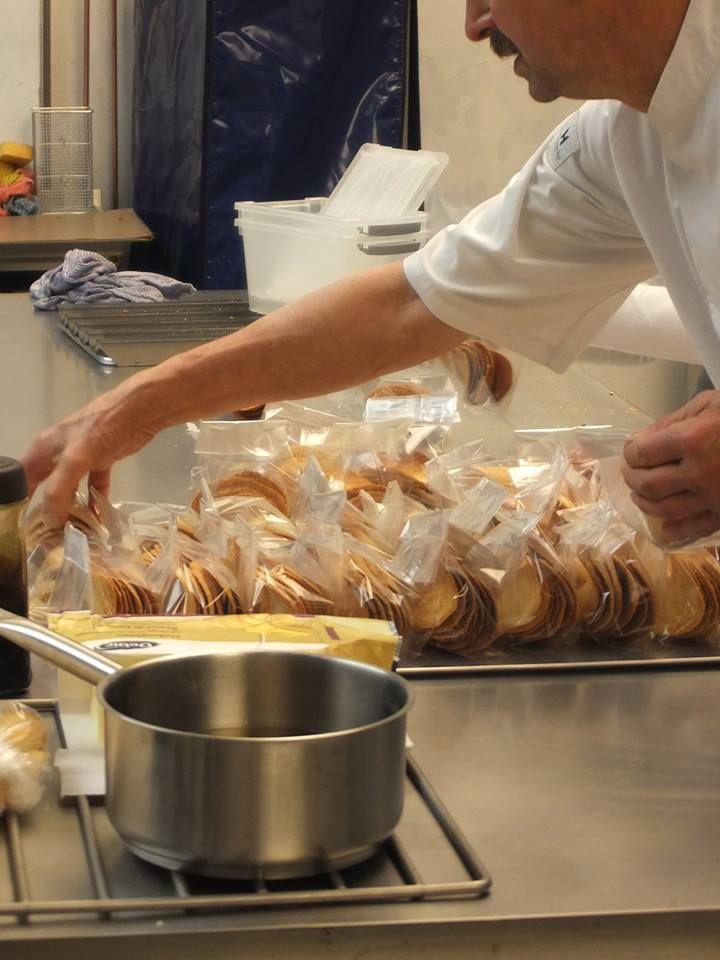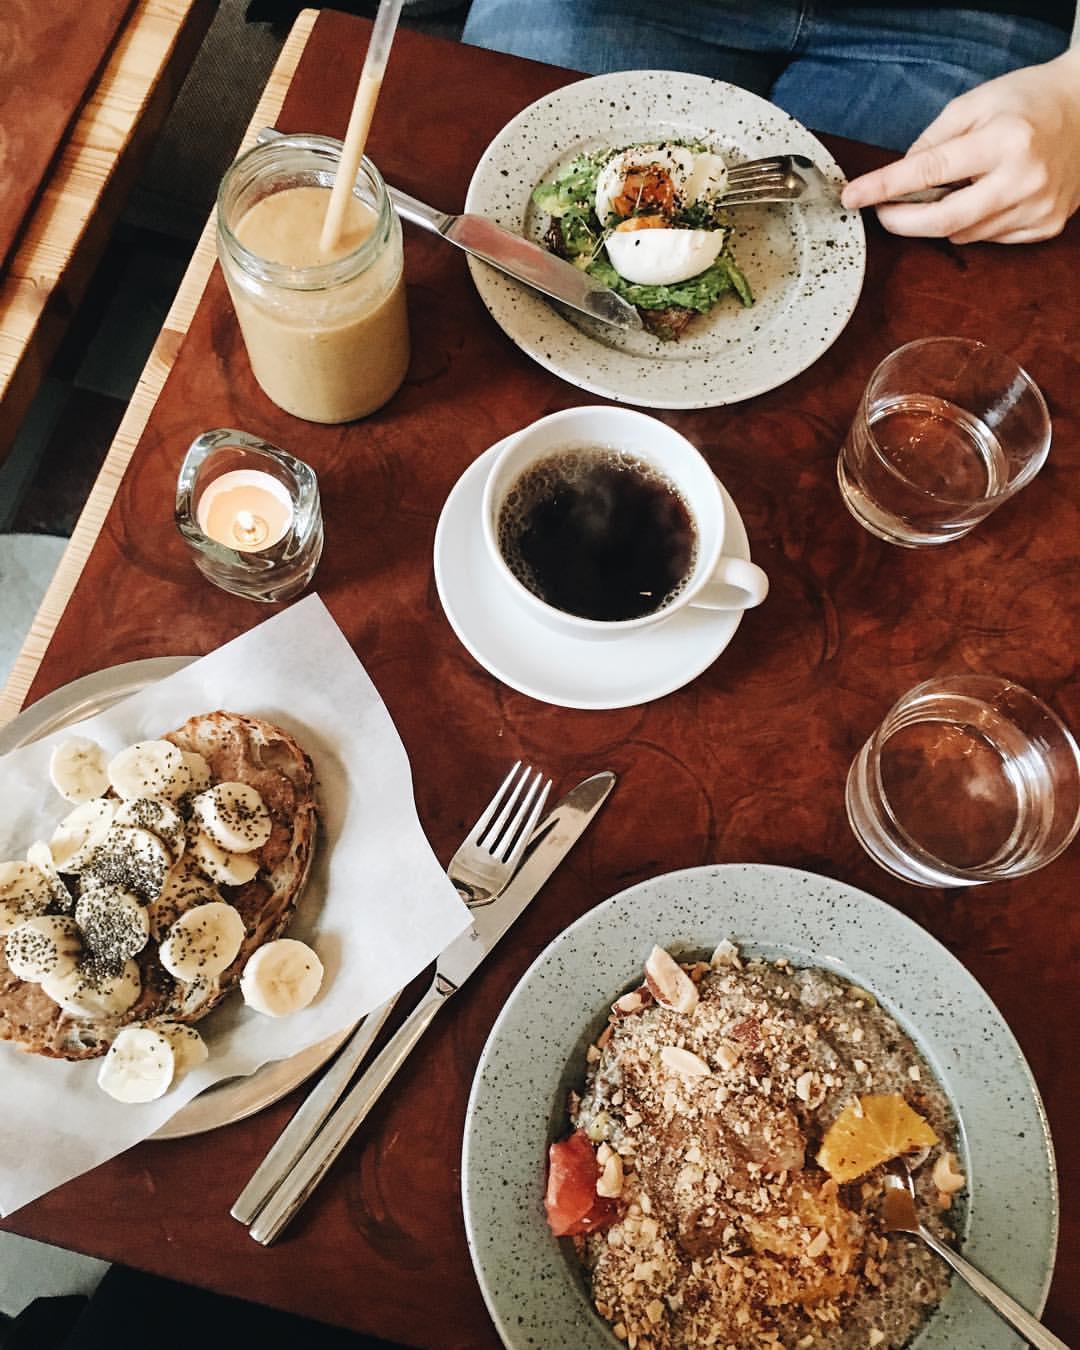The first image is the image on the left, the second image is the image on the right. For the images displayed, is the sentence "A bakery display of assorted cakes and baked goods." factually correct? Answer yes or no. No. The first image is the image on the left, the second image is the image on the right. Considering the images on both sides, is "The left image shows rows of bakery items on display shelves, and includes brown-frosted log shapesnext to white frosted treats garnished with red berries." valid? Answer yes or no. No. 